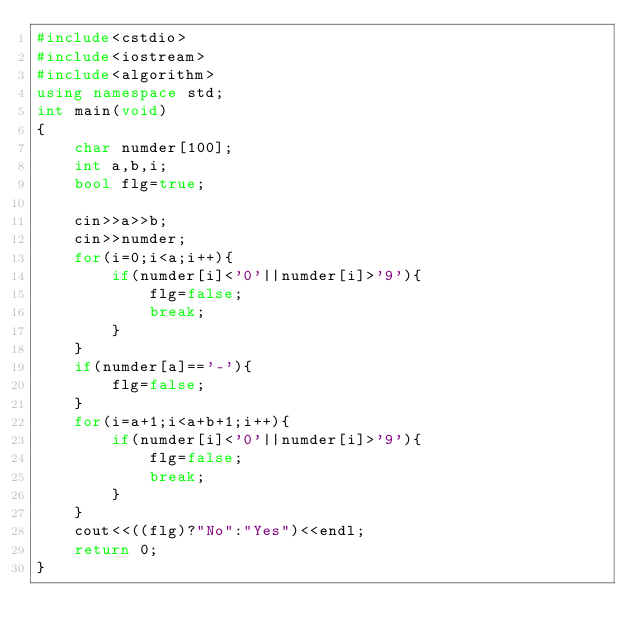Convert code to text. <code><loc_0><loc_0><loc_500><loc_500><_C++_>#include<cstdio>
#include<iostream>
#include<algorithm>
using namespace std;
int main(void)
{
	char numder[100];
	int a,b,i;
	bool flg=true;
	
	cin>>a>>b;
	cin>>numder;
	for(i=0;i<a;i++){
		if(numder[i]<'0'||numder[i]>'9'){
			flg=false;
			break;
		}
	}
	if(numder[a]=='-'){
		flg=false;
	}
	for(i=a+1;i<a+b+1;i++){
		if(numder[i]<'0'||numder[i]>'9'){
			flg=false;
			break;
		}
	}
	cout<<((flg)?"No":"Yes")<<endl;
	return 0;
}</code> 